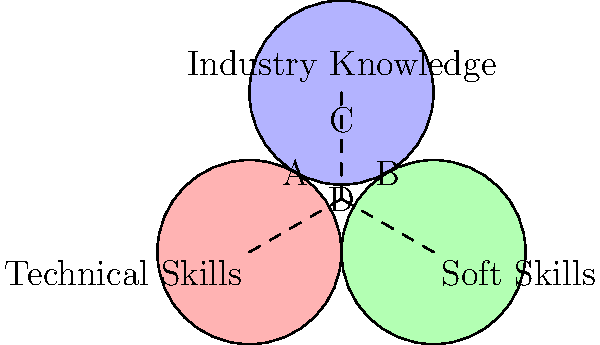Based on the Venn diagram showing overlapping skill sets desired by different employers, which area represents candidates who possess a combination of technical skills, soft skills, and industry knowledge? To answer this question, let's analyze the Venn diagram step-by-step:

1. The diagram consists of three overlapping circles, each representing a different skill set:
   - The red circle (left) represents Technical Skills
   - The green circle (right) represents Soft Skills
   - The blue circle (top) represents Industry Knowledge

2. The overlapping areas represent combinations of these skill sets:
   - Area A: Technical Skills + Industry Knowledge
   - Area B: Soft Skills + Industry Knowledge
   - Area C: Technical Skills + Soft Skills

3. The central area where all three circles overlap is labeled "D". This area represents the intersection of all three skill sets.

4. Candidates who possess a combination of technical skills, soft skills, and industry knowledge would fall into the area where all three circles intersect.

5. Therefore, the area that represents candidates with all three skill sets is area D, the central overlapping region.
Answer: D 